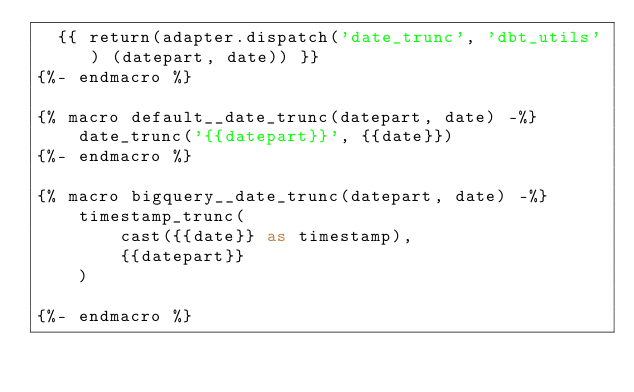<code> <loc_0><loc_0><loc_500><loc_500><_SQL_>  {{ return(adapter.dispatch('date_trunc', 'dbt_utils') (datepart, date)) }}
{%- endmacro %}

{% macro default__date_trunc(datepart, date) -%}
    date_trunc('{{datepart}}', {{date}})
{%- endmacro %}

{% macro bigquery__date_trunc(datepart, date) -%}
    timestamp_trunc(
        cast({{date}} as timestamp),
        {{datepart}}
    )

{%- endmacro %}
</code> 